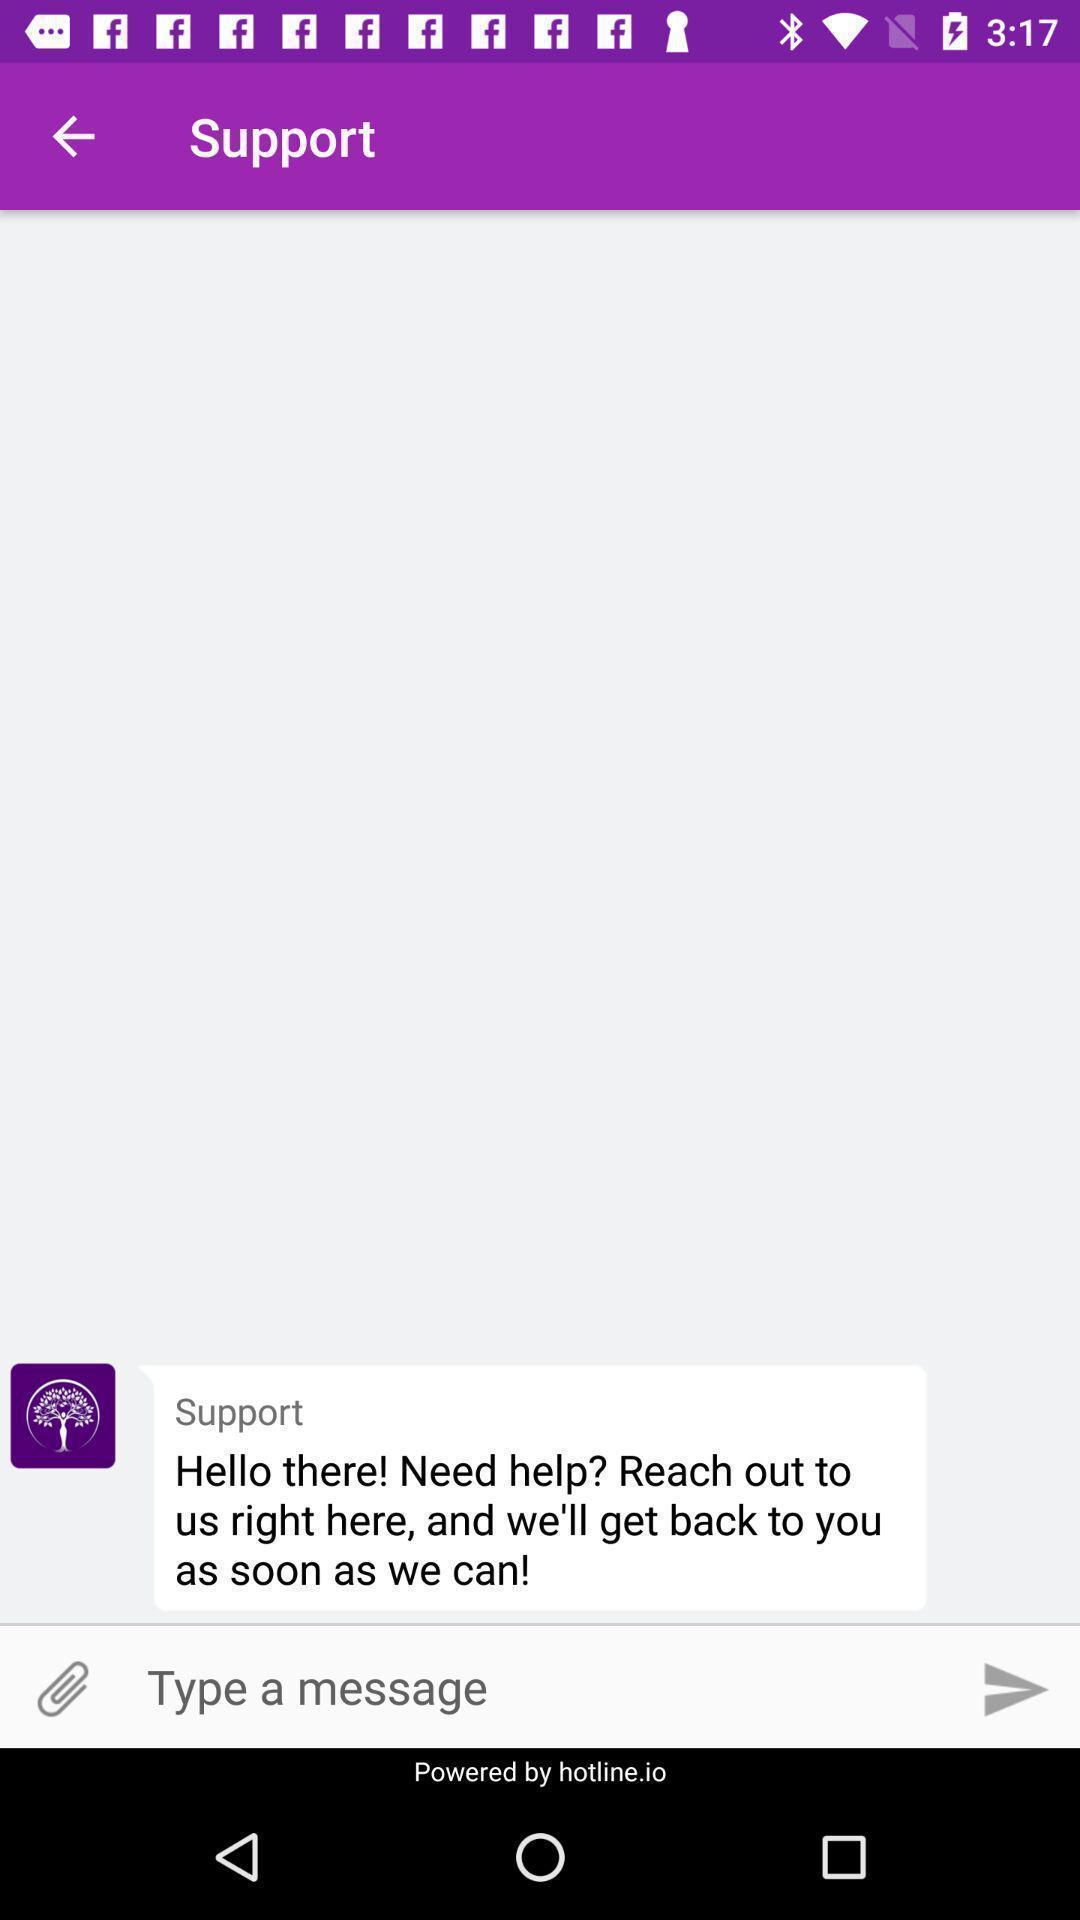Provide a textual representation of this image. Support page. 